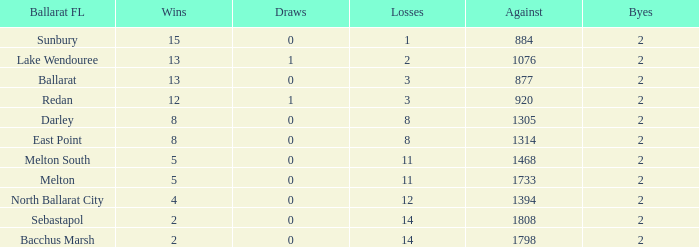What is the count of "against" with "byes" below 2? None. I'm looking to parse the entire table for insights. Could you assist me with that? {'header': ['Ballarat FL', 'Wins', 'Draws', 'Losses', 'Against', 'Byes'], 'rows': [['Sunbury', '15', '0', '1', '884', '2'], ['Lake Wendouree', '13', '1', '2', '1076', '2'], ['Ballarat', '13', '0', '3', '877', '2'], ['Redan', '12', '1', '3', '920', '2'], ['Darley', '8', '0', '8', '1305', '2'], ['East Point', '8', '0', '8', '1314', '2'], ['Melton South', '5', '0', '11', '1468', '2'], ['Melton', '5', '0', '11', '1733', '2'], ['North Ballarat City', '4', '0', '12', '1394', '2'], ['Sebastapol', '2', '0', '14', '1808', '2'], ['Bacchus Marsh', '2', '0', '14', '1798', '2']]} 